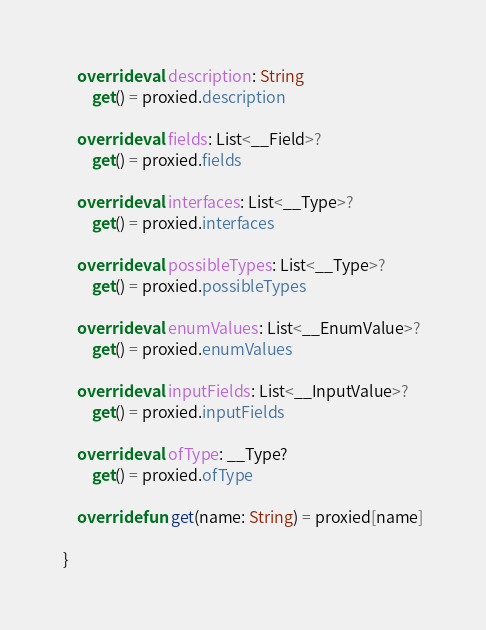Convert code to text. <code><loc_0><loc_0><loc_500><loc_500><_Kotlin_>    override val description: String
        get() = proxied.description

    override val fields: List<__Field>?
        get() = proxied.fields

    override val interfaces: List<__Type>?
        get() = proxied.interfaces

    override val possibleTypes: List<__Type>?
        get() = proxied.possibleTypes

    override val enumValues: List<__EnumValue>?
        get() = proxied.enumValues

    override val inputFields: List<__InputValue>?
        get() = proxied.inputFields

    override val ofType: __Type?
        get() = proxied.ofType

    override fun get(name: String) = proxied[name]

}
</code> 